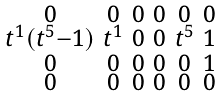<formula> <loc_0><loc_0><loc_500><loc_500>\begin{smallmatrix} 0 & 0 & 0 & 0 & 0 & 0 \\ t ^ { 1 } ( t ^ { 5 } - 1 ) & t ^ { 1 } & 0 & 0 & t ^ { 5 } & 1 \\ 0 & 0 & 0 & 0 & 0 & 1 \\ 0 & 0 & 0 & 0 & 0 & 0 \end{smallmatrix}</formula> 